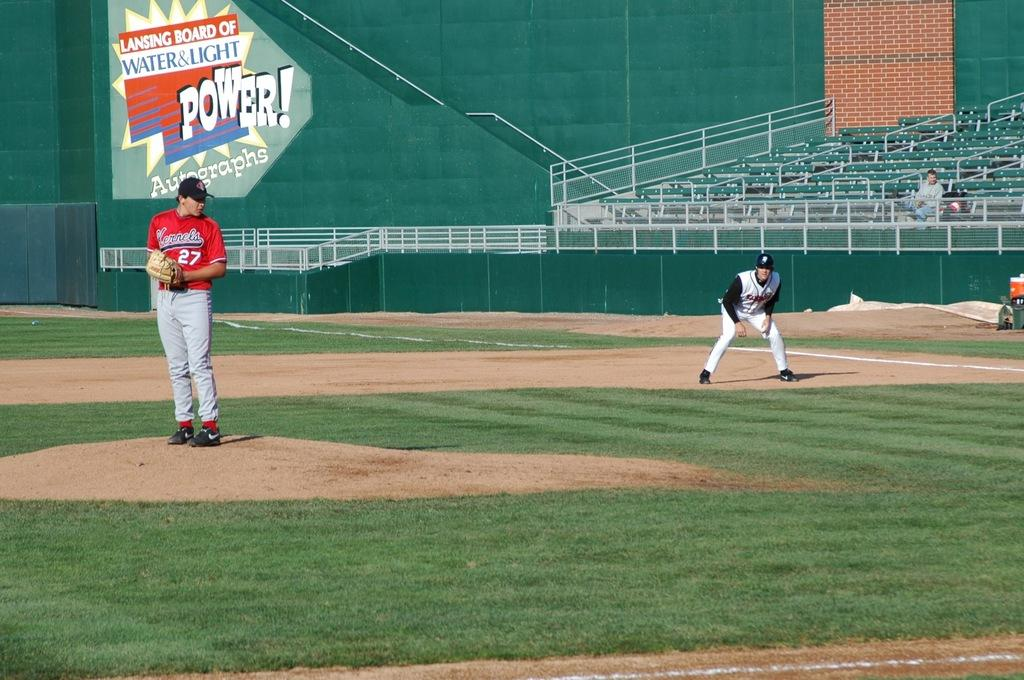<image>
Share a concise interpretation of the image provided. Baseball player in front of a sign Lansing Board of Water & Light 